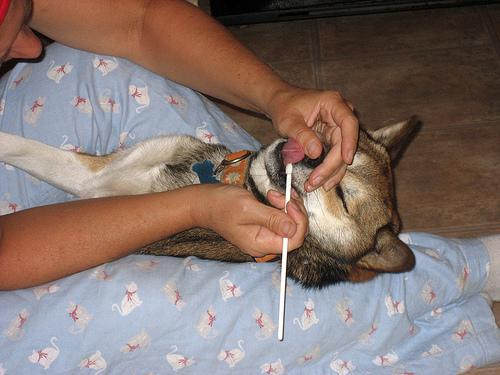Question: what type of animal?
Choices:
A. A dog.
B. A chinchilla.
C. A guinea pig.
D. A wild fox.
Answer with the letter. Answer: A Question: what color are the girls pants?
Choices:
A. Blue.
B. Green.
C. Pink.
D. White.
Answer with the letter. Answer: A Question: who is holding the dog?
Choices:
A. A man.
B. A woman.
C. A cute little girl.
D. A wounded warrior.
Answer with the letter. Answer: B Question: why is the woman holding the dog?
Choices:
A. Boarding the aircraft.
B. So the dog will not step in the puddle.
C. To keep it away from the bigger dog.
D. Cleaning.
Answer with the letter. Answer: D Question: how many dogs?
Choices:
A. 1.
B. 3.
C. 6.
D. 7.
Answer with the letter. Answer: A 